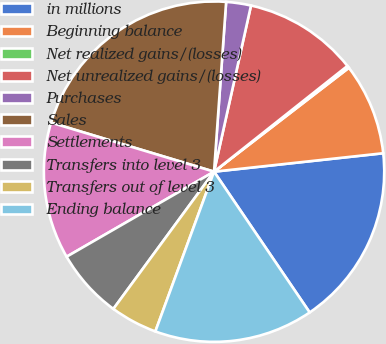<chart> <loc_0><loc_0><loc_500><loc_500><pie_chart><fcel>in millions<fcel>Beginning balance<fcel>Net realized gains/(losses)<fcel>Net unrealized gains/(losses)<fcel>Purchases<fcel>Sales<fcel>Settlements<fcel>Transfers into level 3<fcel>Transfers out of level 3<fcel>Ending balance<nl><fcel>17.23%<fcel>8.72%<fcel>0.22%<fcel>10.85%<fcel>2.35%<fcel>21.48%<fcel>12.98%<fcel>6.6%<fcel>4.47%<fcel>15.1%<nl></chart> 